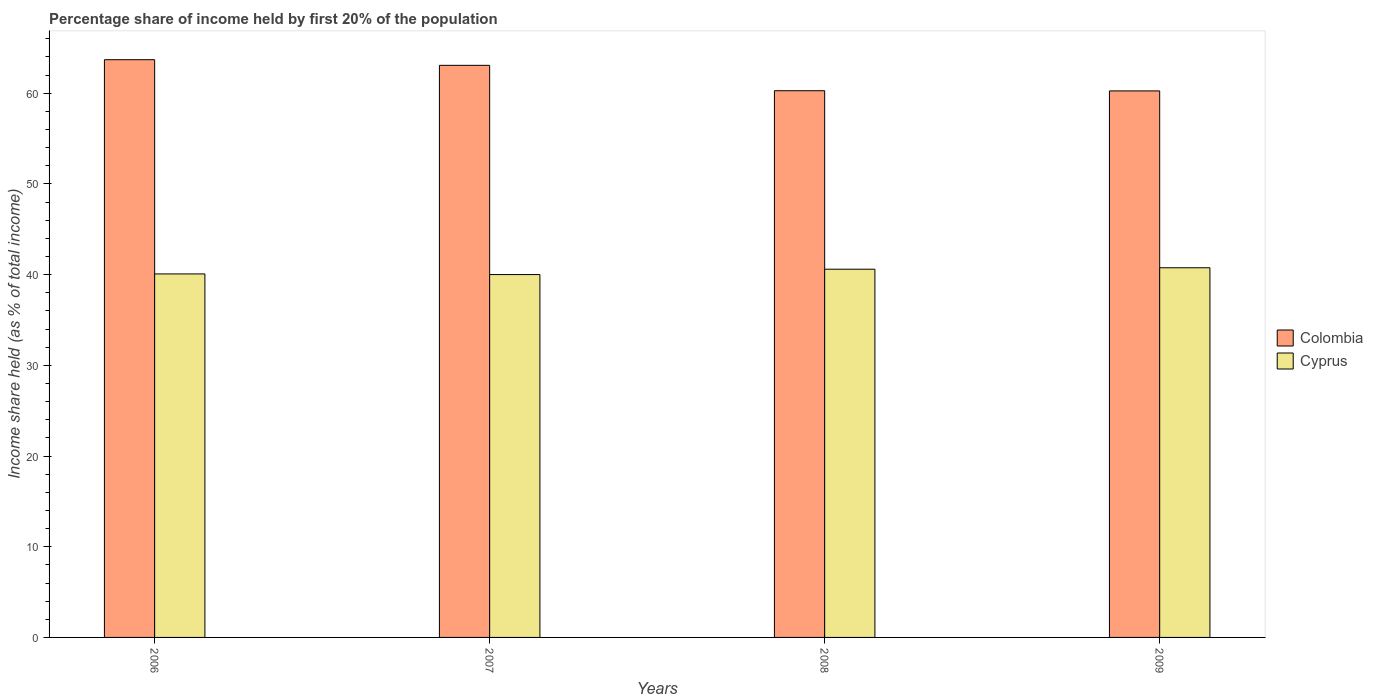How many different coloured bars are there?
Offer a terse response. 2. How many bars are there on the 2nd tick from the left?
Offer a very short reply. 2. How many bars are there on the 2nd tick from the right?
Your answer should be very brief. 2. What is the share of income held by first 20% of the population in Cyprus in 2007?
Your response must be concise. 40.01. Across all years, what is the maximum share of income held by first 20% of the population in Colombia?
Make the answer very short. 63.7. Across all years, what is the minimum share of income held by first 20% of the population in Cyprus?
Offer a very short reply. 40.01. In which year was the share of income held by first 20% of the population in Colombia maximum?
Provide a short and direct response. 2006. In which year was the share of income held by first 20% of the population in Cyprus minimum?
Your response must be concise. 2007. What is the total share of income held by first 20% of the population in Cyprus in the graph?
Your response must be concise. 161.45. What is the difference between the share of income held by first 20% of the population in Colombia in 2007 and that in 2009?
Ensure brevity in your answer.  2.82. What is the difference between the share of income held by first 20% of the population in Cyprus in 2008 and the share of income held by first 20% of the population in Colombia in 2006?
Your response must be concise. -23.1. What is the average share of income held by first 20% of the population in Cyprus per year?
Your answer should be compact. 40.36. In the year 2008, what is the difference between the share of income held by first 20% of the population in Cyprus and share of income held by first 20% of the population in Colombia?
Your answer should be compact. -19.68. What is the ratio of the share of income held by first 20% of the population in Cyprus in 2006 to that in 2007?
Make the answer very short. 1. What is the difference between the highest and the second highest share of income held by first 20% of the population in Cyprus?
Your answer should be very brief. 0.16. In how many years, is the share of income held by first 20% of the population in Cyprus greater than the average share of income held by first 20% of the population in Cyprus taken over all years?
Provide a short and direct response. 2. What does the 2nd bar from the right in 2009 represents?
Provide a succinct answer. Colombia. What is the difference between two consecutive major ticks on the Y-axis?
Give a very brief answer. 10. Are the values on the major ticks of Y-axis written in scientific E-notation?
Give a very brief answer. No. Does the graph contain any zero values?
Keep it short and to the point. No. Does the graph contain grids?
Offer a terse response. No. What is the title of the graph?
Keep it short and to the point. Percentage share of income held by first 20% of the population. What is the label or title of the Y-axis?
Provide a short and direct response. Income share held (as % of total income). What is the Income share held (as % of total income) of Colombia in 2006?
Offer a terse response. 63.7. What is the Income share held (as % of total income) in Cyprus in 2006?
Your answer should be very brief. 40.08. What is the Income share held (as % of total income) of Colombia in 2007?
Your answer should be very brief. 63.08. What is the Income share held (as % of total income) in Cyprus in 2007?
Make the answer very short. 40.01. What is the Income share held (as % of total income) in Colombia in 2008?
Ensure brevity in your answer.  60.28. What is the Income share held (as % of total income) in Cyprus in 2008?
Keep it short and to the point. 40.6. What is the Income share held (as % of total income) in Colombia in 2009?
Your answer should be compact. 60.26. What is the Income share held (as % of total income) of Cyprus in 2009?
Offer a very short reply. 40.76. Across all years, what is the maximum Income share held (as % of total income) of Colombia?
Your response must be concise. 63.7. Across all years, what is the maximum Income share held (as % of total income) in Cyprus?
Your answer should be very brief. 40.76. Across all years, what is the minimum Income share held (as % of total income) of Colombia?
Keep it short and to the point. 60.26. Across all years, what is the minimum Income share held (as % of total income) in Cyprus?
Provide a short and direct response. 40.01. What is the total Income share held (as % of total income) of Colombia in the graph?
Give a very brief answer. 247.32. What is the total Income share held (as % of total income) in Cyprus in the graph?
Offer a terse response. 161.45. What is the difference between the Income share held (as % of total income) of Colombia in 2006 and that in 2007?
Make the answer very short. 0.62. What is the difference between the Income share held (as % of total income) in Cyprus in 2006 and that in 2007?
Provide a succinct answer. 0.07. What is the difference between the Income share held (as % of total income) in Colombia in 2006 and that in 2008?
Keep it short and to the point. 3.42. What is the difference between the Income share held (as % of total income) of Cyprus in 2006 and that in 2008?
Make the answer very short. -0.52. What is the difference between the Income share held (as % of total income) of Colombia in 2006 and that in 2009?
Your answer should be compact. 3.44. What is the difference between the Income share held (as % of total income) of Cyprus in 2006 and that in 2009?
Offer a terse response. -0.68. What is the difference between the Income share held (as % of total income) of Colombia in 2007 and that in 2008?
Your answer should be compact. 2.8. What is the difference between the Income share held (as % of total income) of Cyprus in 2007 and that in 2008?
Give a very brief answer. -0.59. What is the difference between the Income share held (as % of total income) of Colombia in 2007 and that in 2009?
Your answer should be very brief. 2.82. What is the difference between the Income share held (as % of total income) of Cyprus in 2007 and that in 2009?
Keep it short and to the point. -0.75. What is the difference between the Income share held (as % of total income) of Cyprus in 2008 and that in 2009?
Ensure brevity in your answer.  -0.16. What is the difference between the Income share held (as % of total income) in Colombia in 2006 and the Income share held (as % of total income) in Cyprus in 2007?
Make the answer very short. 23.69. What is the difference between the Income share held (as % of total income) in Colombia in 2006 and the Income share held (as % of total income) in Cyprus in 2008?
Make the answer very short. 23.1. What is the difference between the Income share held (as % of total income) in Colombia in 2006 and the Income share held (as % of total income) in Cyprus in 2009?
Give a very brief answer. 22.94. What is the difference between the Income share held (as % of total income) of Colombia in 2007 and the Income share held (as % of total income) of Cyprus in 2008?
Give a very brief answer. 22.48. What is the difference between the Income share held (as % of total income) of Colombia in 2007 and the Income share held (as % of total income) of Cyprus in 2009?
Provide a short and direct response. 22.32. What is the difference between the Income share held (as % of total income) in Colombia in 2008 and the Income share held (as % of total income) in Cyprus in 2009?
Your answer should be very brief. 19.52. What is the average Income share held (as % of total income) in Colombia per year?
Your answer should be compact. 61.83. What is the average Income share held (as % of total income) in Cyprus per year?
Your response must be concise. 40.36. In the year 2006, what is the difference between the Income share held (as % of total income) in Colombia and Income share held (as % of total income) in Cyprus?
Ensure brevity in your answer.  23.62. In the year 2007, what is the difference between the Income share held (as % of total income) in Colombia and Income share held (as % of total income) in Cyprus?
Provide a succinct answer. 23.07. In the year 2008, what is the difference between the Income share held (as % of total income) of Colombia and Income share held (as % of total income) of Cyprus?
Your answer should be very brief. 19.68. What is the ratio of the Income share held (as % of total income) of Colombia in 2006 to that in 2007?
Make the answer very short. 1.01. What is the ratio of the Income share held (as % of total income) of Cyprus in 2006 to that in 2007?
Provide a short and direct response. 1. What is the ratio of the Income share held (as % of total income) of Colombia in 2006 to that in 2008?
Ensure brevity in your answer.  1.06. What is the ratio of the Income share held (as % of total income) in Cyprus in 2006 to that in 2008?
Your answer should be very brief. 0.99. What is the ratio of the Income share held (as % of total income) in Colombia in 2006 to that in 2009?
Make the answer very short. 1.06. What is the ratio of the Income share held (as % of total income) of Cyprus in 2006 to that in 2009?
Keep it short and to the point. 0.98. What is the ratio of the Income share held (as % of total income) in Colombia in 2007 to that in 2008?
Provide a short and direct response. 1.05. What is the ratio of the Income share held (as % of total income) in Cyprus in 2007 to that in 2008?
Offer a very short reply. 0.99. What is the ratio of the Income share held (as % of total income) of Colombia in 2007 to that in 2009?
Offer a terse response. 1.05. What is the ratio of the Income share held (as % of total income) of Cyprus in 2007 to that in 2009?
Offer a terse response. 0.98. What is the difference between the highest and the second highest Income share held (as % of total income) in Colombia?
Keep it short and to the point. 0.62. What is the difference between the highest and the second highest Income share held (as % of total income) of Cyprus?
Provide a succinct answer. 0.16. What is the difference between the highest and the lowest Income share held (as % of total income) of Colombia?
Provide a succinct answer. 3.44. 